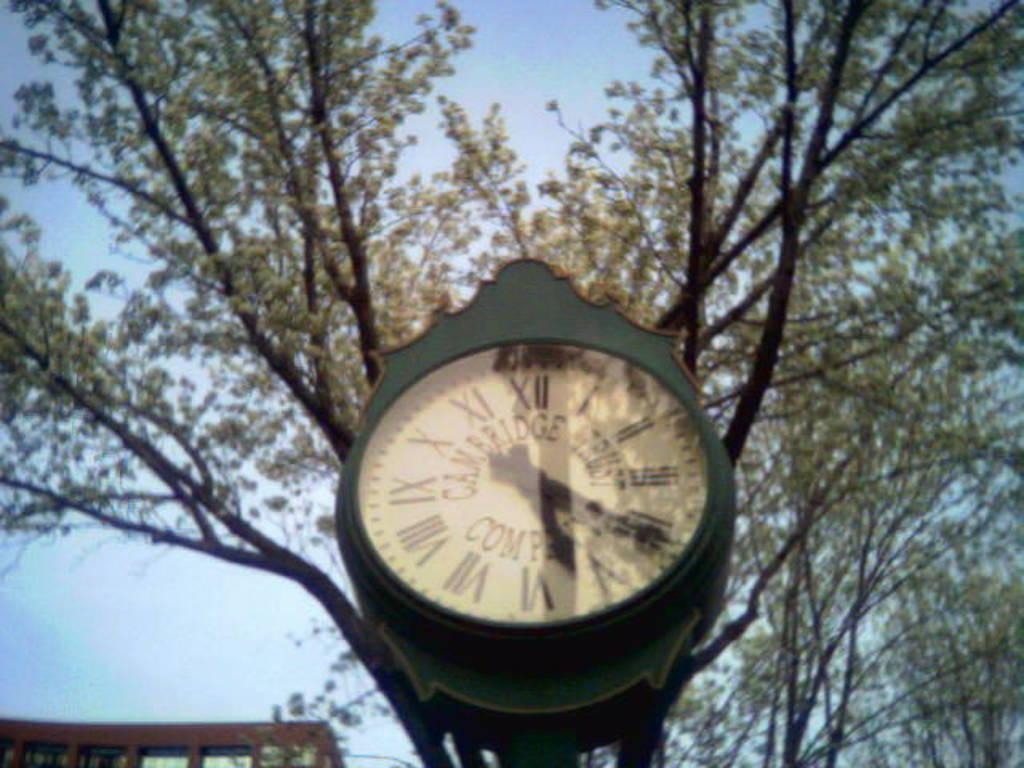What object in the image can be used to tell time? There is a clock in the image that can be used to tell time. What type of natural elements can be seen in the image? There are trees in the image. What type of man-made structure is visible in the image? There is a building in the image. What can be seen in the background of the image? The sky is visible in the background of the image. What type of line can be seen on the basketball court in the image? There is no basketball court or line present in the image. 